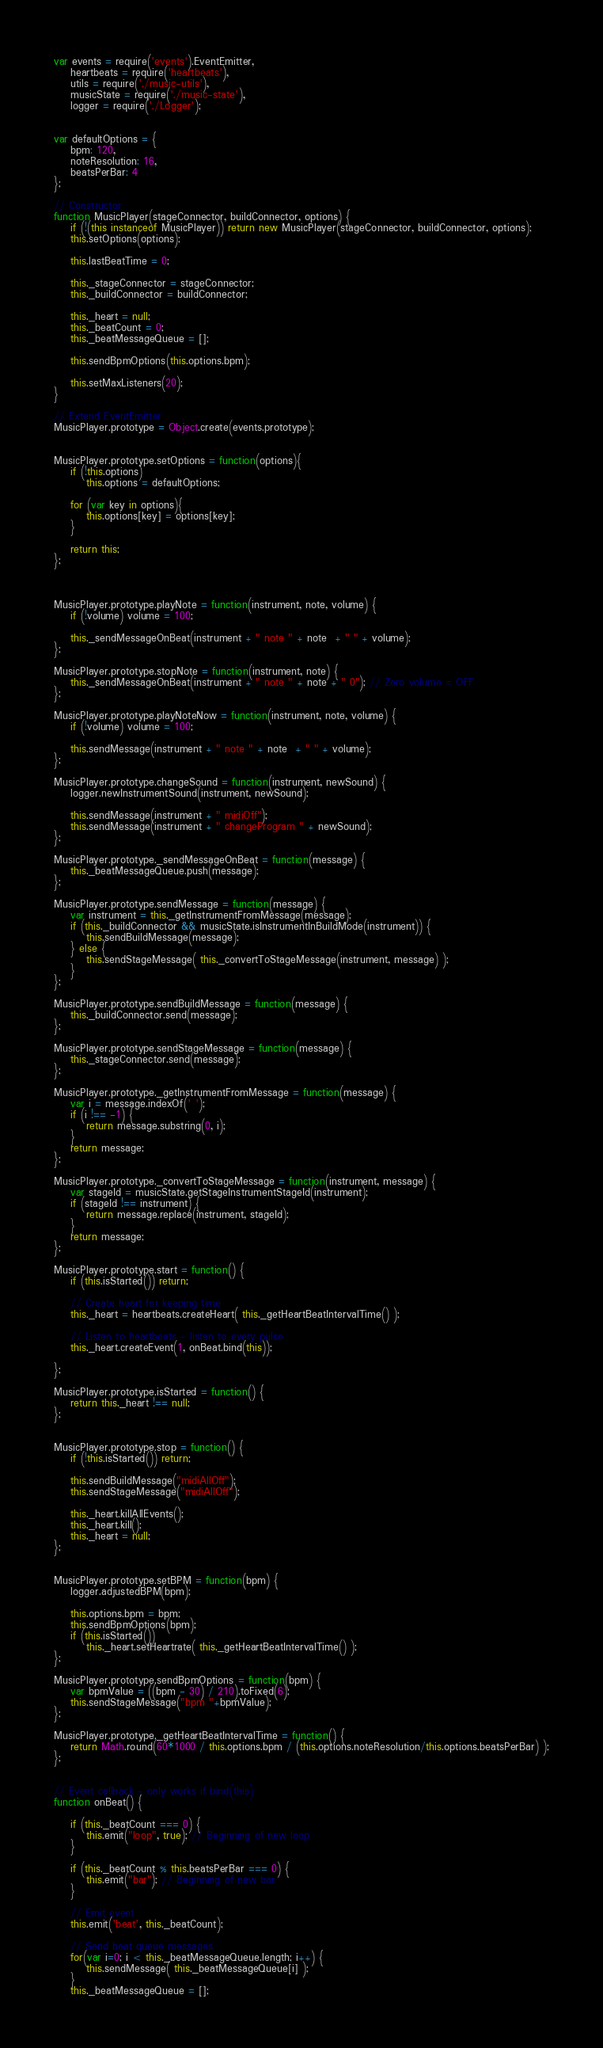Convert code to text. <code><loc_0><loc_0><loc_500><loc_500><_JavaScript_>var events = require('events').EventEmitter,
    heartbeats = require('heartbeats'),
    utils = require('./music-utils'),
    musicState = require('./music-state'),
    logger = require('./Logger');


var defaultOptions = {
    bpm: 120,
    noteResolution: 16,
    beatsPerBar: 4
};

// Constructor
function MusicPlayer(stageConnector, buildConnector, options) {
    if (!(this instanceof MusicPlayer)) return new MusicPlayer(stageConnector, buildConnector, options);
    this.setOptions(options);

    this.lastBeatTime = 0;

    this._stageConnector = stageConnector;
    this._buildConnector = buildConnector;

    this._heart = null;
    this._beatCount = 0;
    this._beatMessageQueue = [];

    this.sendBpmOptions(this.options.bpm);

    this.setMaxListeners(20);
}

// Extend EventEmitter
MusicPlayer.prototype = Object.create(events.prototype);


MusicPlayer.prototype.setOptions = function(options){
    if (!this.options)
        this.options = defaultOptions;

    for (var key in options){
        this.options[key] = options[key];
    }

    return this;
};



MusicPlayer.prototype.playNote = function(instrument, note, volume) {
    if (!volume) volume = 100;

    this._sendMessageOnBeat(instrument + " note " + note  + " " + volume);
};

MusicPlayer.prototype.stopNote = function(instrument, note) {
    this._sendMessageOnBeat(instrument + " note " + note + " 0"); // Zero volume = OFF
};

MusicPlayer.prototype.playNoteNow = function(instrument, note, volume) {
    if (!volume) volume = 100;

    this.sendMessage(instrument + " note " + note  + " " + volume);
};

MusicPlayer.prototype.changeSound = function(instrument, newSound) {
    logger.newInstrumentSound(instrument, newSound);

    this.sendMessage(instrument + " midiOff");
    this.sendMessage(instrument + " changeProgram " + newSound);
};

MusicPlayer.prototype._sendMessageOnBeat = function(message) {
    this._beatMessageQueue.push(message);
};

MusicPlayer.prototype.sendMessage = function(message) {
    var instrument = this._getInstrumentFromMessage(message);
    if (this._buildConnector && musicState.isInstrumentInBuildMode(instrument)) {
        this.sendBuildMessage(message);
    } else {
        this.sendStageMessage( this._convertToStageMessage(instrument, message) );
    }
};

MusicPlayer.prototype.sendBuildMessage = function(message) {
    this._buildConnector.send(message);
};

MusicPlayer.prototype.sendStageMessage = function(message) {
    this._stageConnector.send(message);
};

MusicPlayer.prototype._getInstrumentFromMessage = function(message) {
    var i = message.indexOf(' ');
    if (i !== -1) {
        return message.substring(0, i);
    }
    return message;
};

MusicPlayer.prototype._convertToStageMessage = function(instrument, message) {
    var stageId = musicState.getStageInstrumentStageId(instrument);
    if (stageId !== instrument) {
        return message.replace(instrument, stageId);
    }
    return message;
};

MusicPlayer.prototype.start = function() {
    if (this.isStarted()) return;

    // Create heart for keeping time
    this._heart = heartbeats.createHeart( this._getHeartBeatIntervalTime() );

    // Listen to heartbeats - listen to every pulse
    this._heart.createEvent(1, onBeat.bind(this));

};

MusicPlayer.prototype.isStarted = function() {
    return this._heart !== null;
};


MusicPlayer.prototype.stop = function() {
    if (!this.isStarted()) return;

    this.sendBuildMessage("midiAllOff");
    this.sendStageMessage("midiAllOff");

    this._heart.killAllEvents();
    this._heart.kill();
    this._heart = null;
};


MusicPlayer.prototype.setBPM = function(bpm) {
    logger.adjustedBPM(bpm);

    this.options.bpm = bpm;
    this.sendBpmOptions(bpm);
    if (this.isStarted())
        this._heart.setHeartrate( this._getHeartBeatIntervalTime() );
};

MusicPlayer.prototype.sendBpmOptions = function(bpm) {
    var bpmValue = ((bpm - 30) / 210).toFixed(6);
    this.sendStageMessage("bpm "+bpmValue);
};

MusicPlayer.prototype._getHeartBeatIntervalTime = function() {
    return Math.round(60*1000 / this.options.bpm / (this.options.noteResolution/this.options.beatsPerBar) );
};


// Event callback - only works if bind(this)
function onBeat() {

    if (this._beatCount === 0) {
        this.emit("loop", true); // Beginning of new loop
    }

    if (this._beatCount % this.beatsPerBar === 0) {
        this.emit("bar"); // Beginning of new bar
    }

    // Emit event
    this.emit('beat', this._beatCount);

    // Send beat queue messages
    for(var i=0; i < this._beatMessageQueue.length; i++) {
        this.sendMessage( this._beatMessageQueue[i] );
    }
    this._beatMessageQueue = [];
</code> 